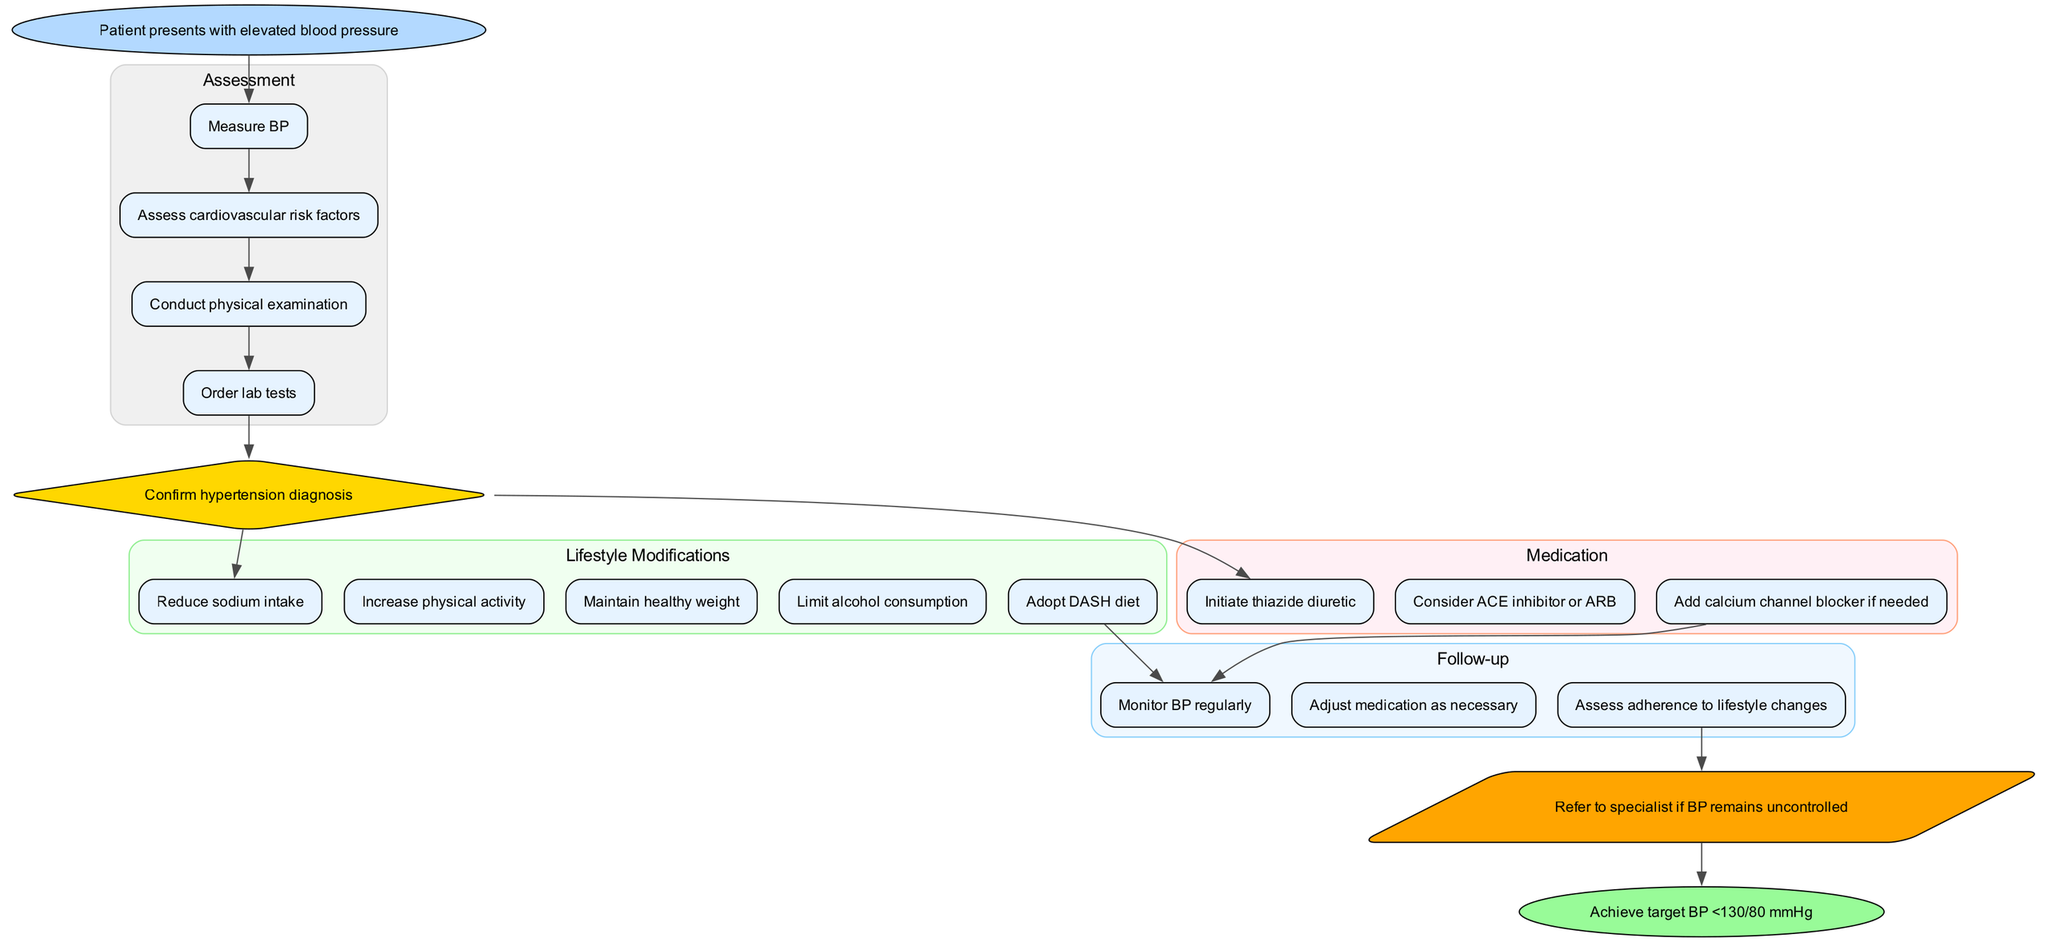What triggers the clinical pathway for managing hypertension? The pathway begins when a patient presents with elevated blood pressure, which initiates the entire process of assessment, diagnosis, and treatment.
Answer: Patient presents with elevated blood pressure How many assessment steps are included? The diagram includes four distinct assessment steps that need to be conducted to evaluate the patient's condition effectively.
Answer: 4 What type of node is used for the diagnosis? The diagnosis node is represented as a diamond shape in the diagram, which is a common representation for decision points in flowcharts.
Answer: Diamond What is the first lifestyle modification suggested? According to the flowchart, the first lifestyle modification recommended after diagnosis is to reduce sodium intake, which is crucial in managing hypertension.
Answer: Reduce sodium intake How is medication first initiated after diagnosis? After confirming the diagnosis of hypertension, the clinical pathway suggests initiating a thiazide diuretic as the first step in the medication regimen.
Answer: Initiate thiazide diuretic What happens if blood pressure remains uncontrolled? If the patient's blood pressure does not come under control after following up, the next step is to refer the patient to a specialist for further management.
Answer: Refer to specialist What is the end goal of the clinical pathway? The ultimate aim of the clinical pathway is to achieve a target blood pressure of less than 130/80 mmHg, which indicates effective management of hypertension.
Answer: Achieve target BP <130/80 mmHg How many follow-up steps are detailed in the diagram? The pathway outlines three specific follow-up actions that should be taken to monitor and adjust the treatment as necessary.
Answer: 3 What dietary approach is recommended in the lifestyle modifications? The clinical pathway suggests adopting the DASH diet as a key dietary strategy to help manage hypertension effectively.
Answer: Adopt DASH diet 